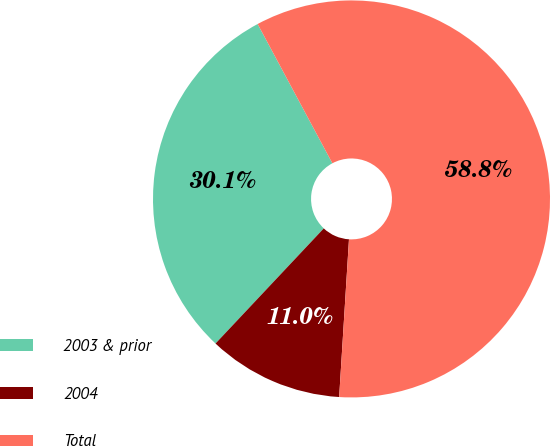Convert chart to OTSL. <chart><loc_0><loc_0><loc_500><loc_500><pie_chart><fcel>2003 & prior<fcel>2004<fcel>Total<nl><fcel>30.15%<fcel>11.02%<fcel>58.83%<nl></chart> 